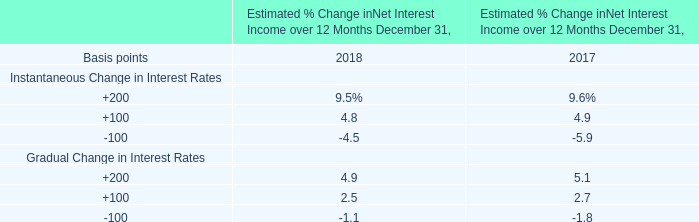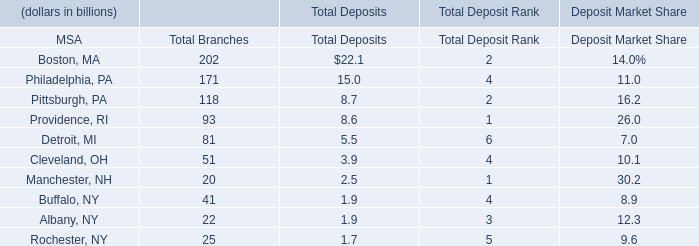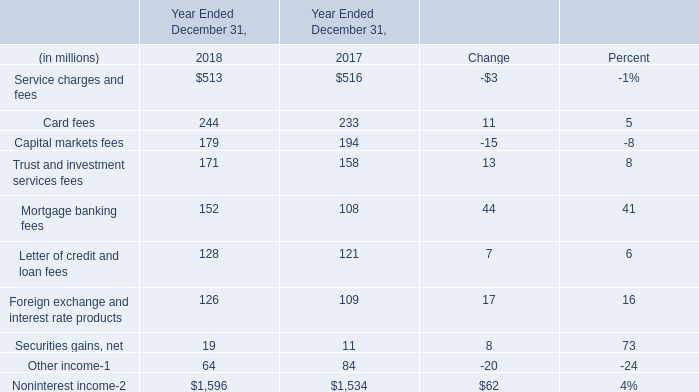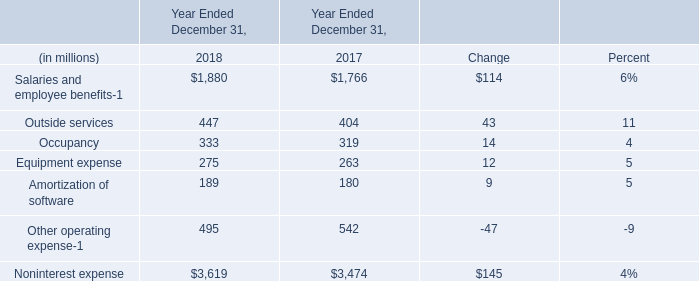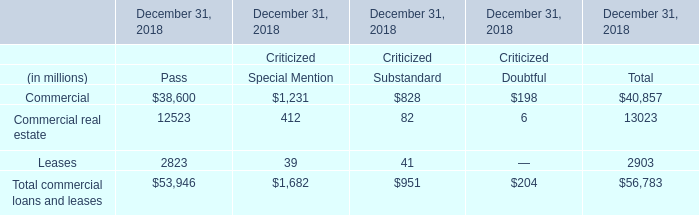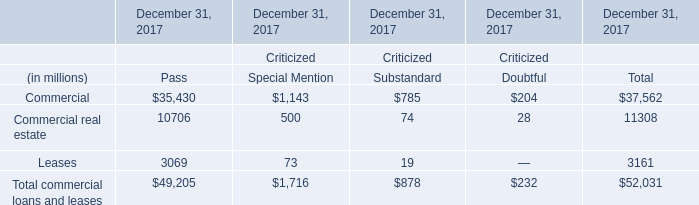What is the difference between the greatest Noninterest income in 2018 and 2017？ (in million) 
Computations: (1596 - 1534)
Answer: 62.0. 